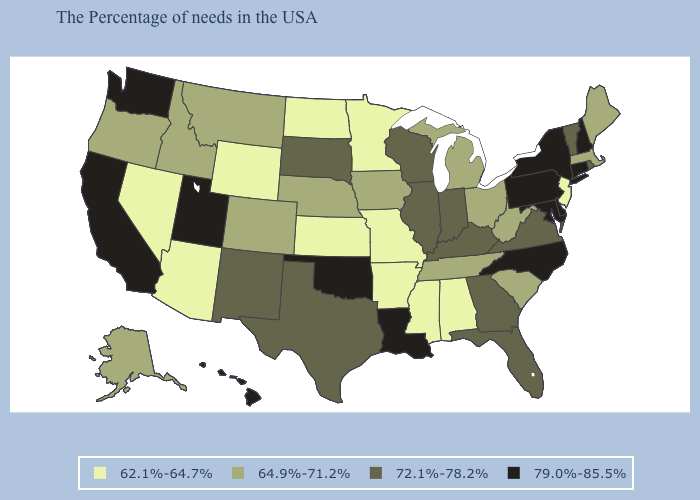Name the states that have a value in the range 72.1%-78.2%?
Keep it brief. Rhode Island, Vermont, Virginia, Florida, Georgia, Kentucky, Indiana, Wisconsin, Illinois, Texas, South Dakota, New Mexico. Does Rhode Island have a lower value than Idaho?
Write a very short answer. No. What is the value of Georgia?
Quick response, please. 72.1%-78.2%. What is the value of New Hampshire?
Quick response, please. 79.0%-85.5%. Among the states that border Florida , which have the lowest value?
Concise answer only. Alabama. What is the highest value in the Northeast ?
Write a very short answer. 79.0%-85.5%. Among the states that border Vermont , which have the lowest value?
Be succinct. Massachusetts. What is the value of California?
Be succinct. 79.0%-85.5%. Which states hav the highest value in the MidWest?
Quick response, please. Indiana, Wisconsin, Illinois, South Dakota. What is the value of New Mexico?
Write a very short answer. 72.1%-78.2%. Name the states that have a value in the range 79.0%-85.5%?
Short answer required. New Hampshire, Connecticut, New York, Delaware, Maryland, Pennsylvania, North Carolina, Louisiana, Oklahoma, Utah, California, Washington, Hawaii. What is the highest value in states that border Washington?
Give a very brief answer. 64.9%-71.2%. Does Tennessee have the lowest value in the South?
Short answer required. No. What is the value of Illinois?
Give a very brief answer. 72.1%-78.2%. Name the states that have a value in the range 79.0%-85.5%?
Write a very short answer. New Hampshire, Connecticut, New York, Delaware, Maryland, Pennsylvania, North Carolina, Louisiana, Oklahoma, Utah, California, Washington, Hawaii. 